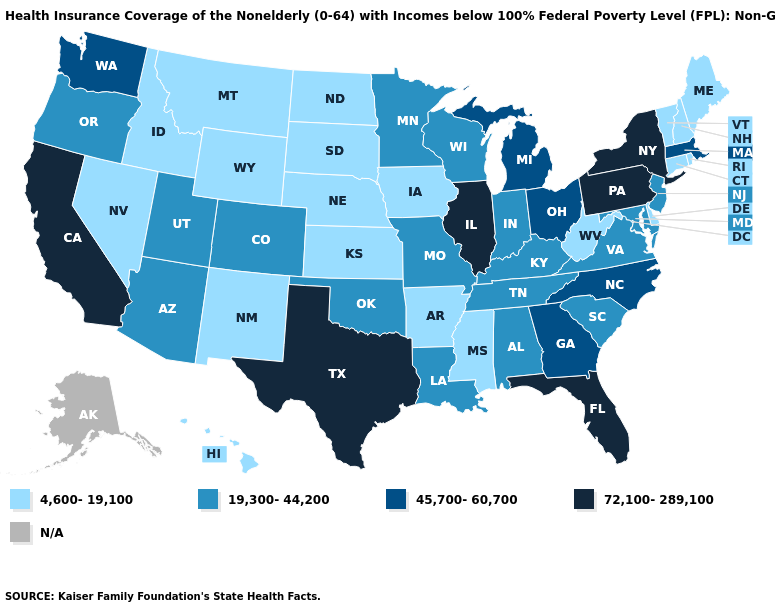Does the map have missing data?
Quick response, please. Yes. Among the states that border Louisiana , does Arkansas have the highest value?
Quick response, please. No. Name the states that have a value in the range 45,700-60,700?
Concise answer only. Georgia, Massachusetts, Michigan, North Carolina, Ohio, Washington. Does Illinois have the highest value in the MidWest?
Be succinct. Yes. Name the states that have a value in the range 45,700-60,700?
Concise answer only. Georgia, Massachusetts, Michigan, North Carolina, Ohio, Washington. Does Nevada have the lowest value in the USA?
Be succinct. Yes. Name the states that have a value in the range N/A?
Write a very short answer. Alaska. What is the highest value in states that border Ohio?
Short answer required. 72,100-289,100. Among the states that border New Mexico , which have the highest value?
Be succinct. Texas. Among the states that border Minnesota , does South Dakota have the highest value?
Quick response, please. No. What is the highest value in the USA?
Short answer required. 72,100-289,100. Does Nebraska have the lowest value in the USA?
Be succinct. Yes. Name the states that have a value in the range N/A?
Keep it brief. Alaska. Does the map have missing data?
Answer briefly. Yes. 